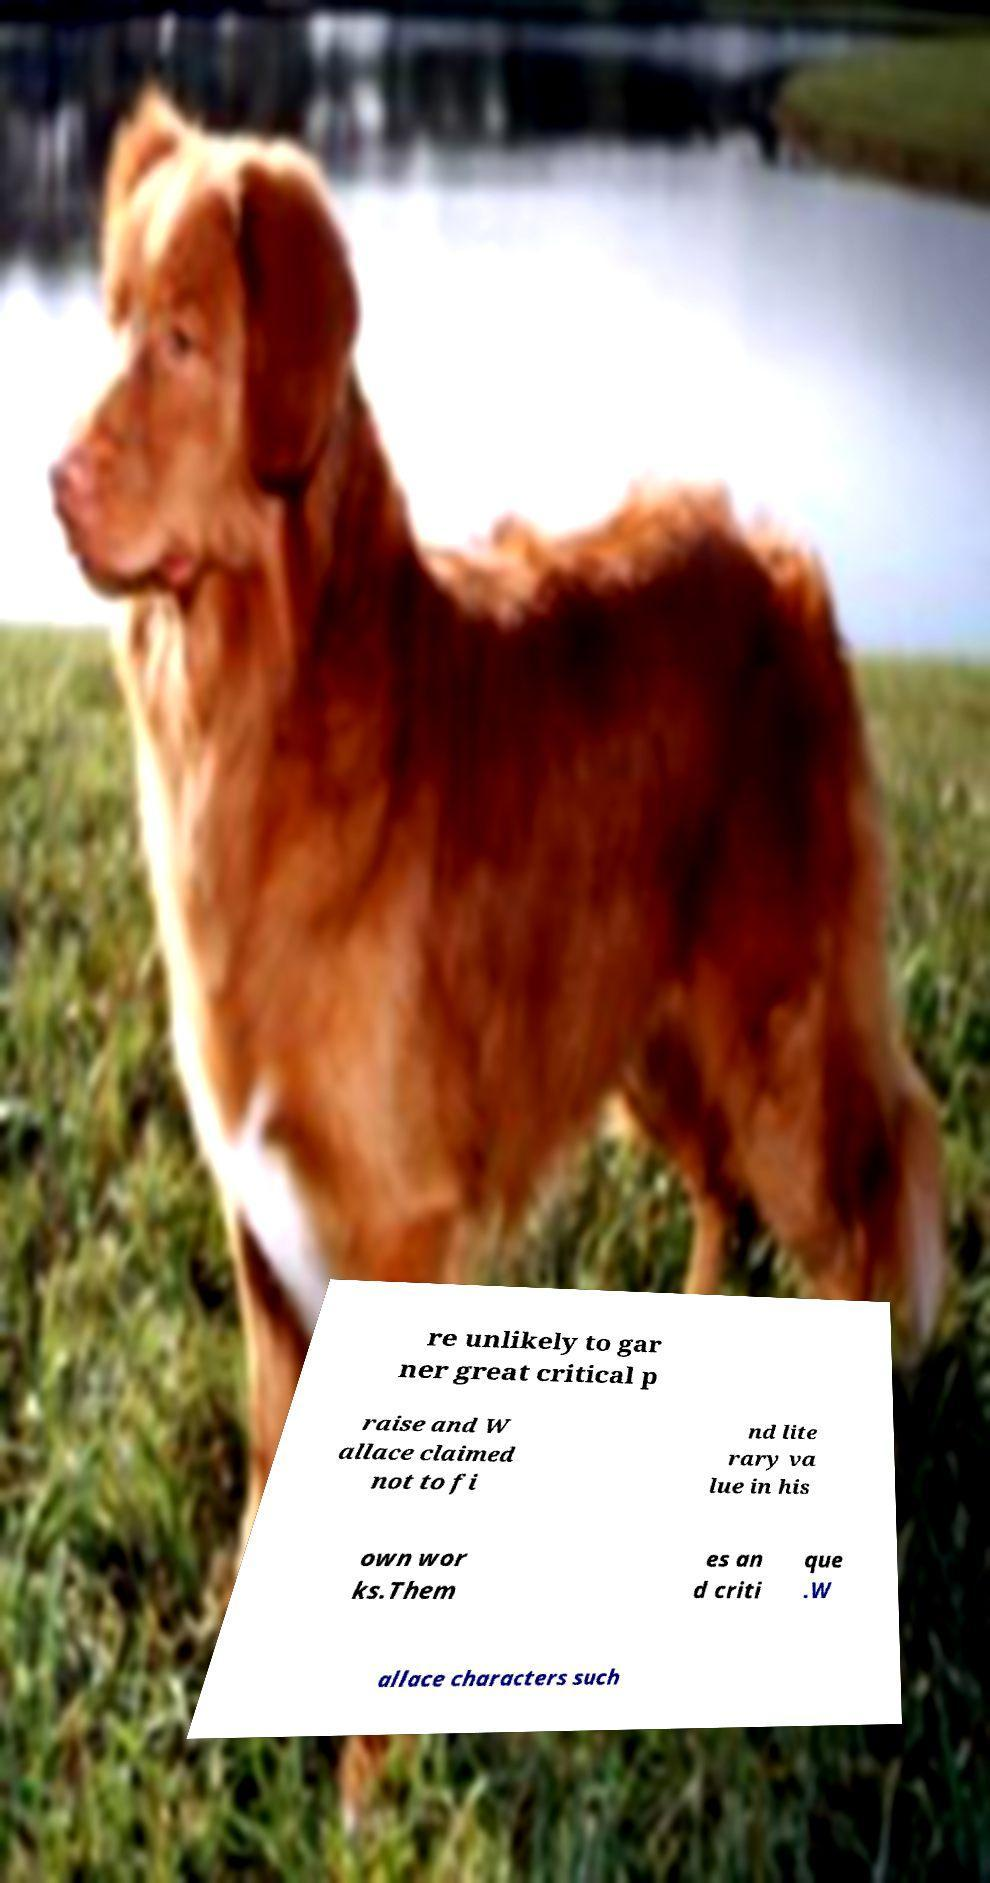Could you assist in decoding the text presented in this image and type it out clearly? re unlikely to gar ner great critical p raise and W allace claimed not to fi nd lite rary va lue in his own wor ks.Them es an d criti que .W allace characters such 